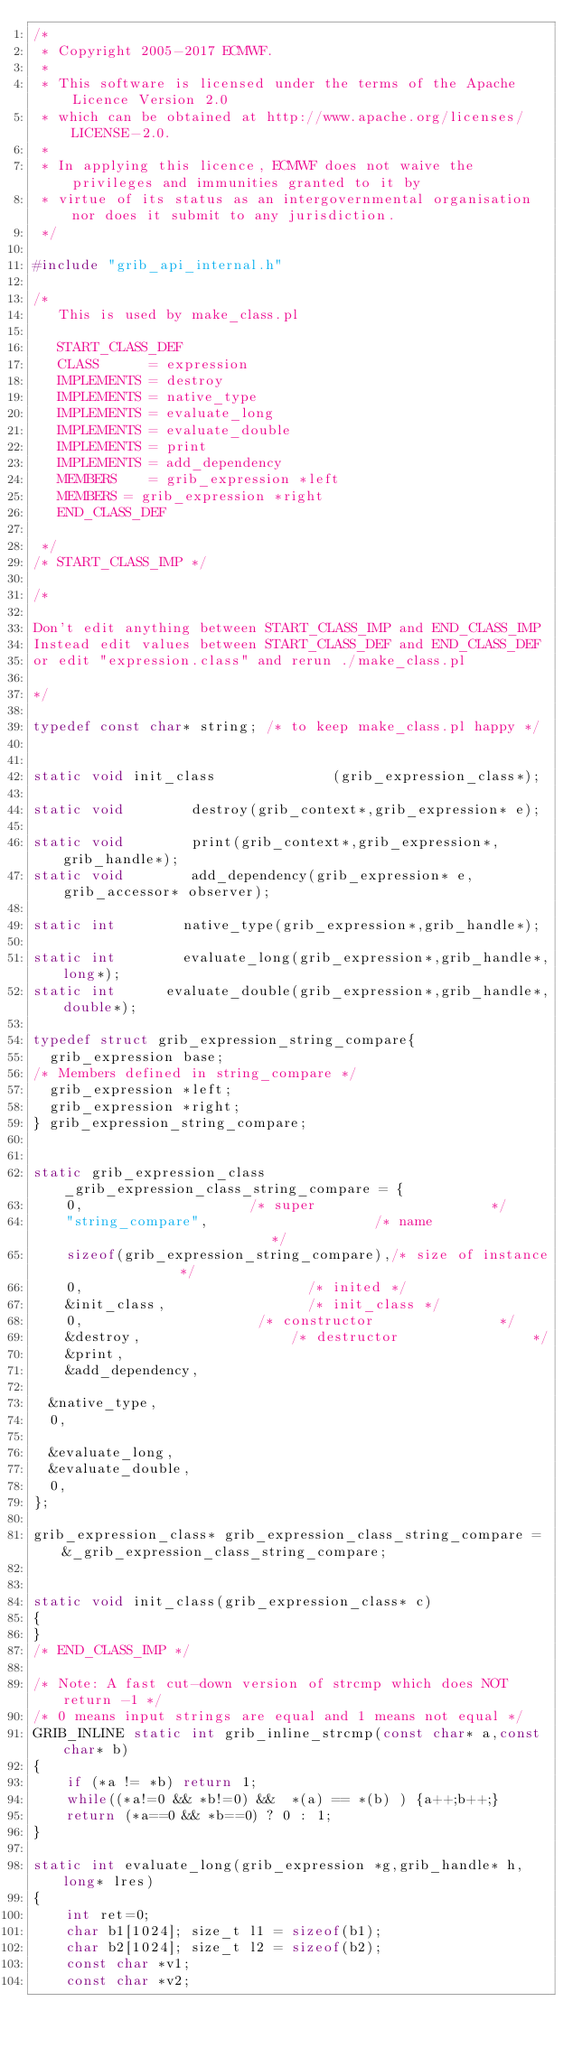Convert code to text. <code><loc_0><loc_0><loc_500><loc_500><_C_>/*
 * Copyright 2005-2017 ECMWF.
 *
 * This software is licensed under the terms of the Apache Licence Version 2.0
 * which can be obtained at http://www.apache.org/licenses/LICENSE-2.0.
 *
 * In applying this licence, ECMWF does not waive the privileges and immunities granted to it by
 * virtue of its status as an intergovernmental organisation nor does it submit to any jurisdiction.
 */

#include "grib_api_internal.h"

/*
   This is used by make_class.pl

   START_CLASS_DEF
   CLASS      = expression
   IMPLEMENTS = destroy
   IMPLEMENTS = native_type
   IMPLEMENTS = evaluate_long
   IMPLEMENTS = evaluate_double
   IMPLEMENTS = print
   IMPLEMENTS = add_dependency
   MEMBERS    = grib_expression *left
   MEMBERS = grib_expression *right
   END_CLASS_DEF

 */
/* START_CLASS_IMP */

/*

Don't edit anything between START_CLASS_IMP and END_CLASS_IMP
Instead edit values between START_CLASS_DEF and END_CLASS_DEF
or edit "expression.class" and rerun ./make_class.pl

*/

typedef const char* string; /* to keep make_class.pl happy */


static void init_class              (grib_expression_class*);

static void        destroy(grib_context*,grib_expression* e);

static void        print(grib_context*,grib_expression*,grib_handle*);
static void        add_dependency(grib_expression* e, grib_accessor* observer);

static int        native_type(grib_expression*,grib_handle*);

static int        evaluate_long(grib_expression*,grib_handle*,long*);
static int      evaluate_double(grib_expression*,grib_handle*,double*);

typedef struct grib_expression_string_compare{
  grib_expression base;
/* Members defined in string_compare */
	grib_expression *left;
	grib_expression *right;
} grib_expression_string_compare;


static grib_expression_class _grib_expression_class_string_compare = {
    0,                    /* super                     */
    "string_compare",                    /* name                      */
    sizeof(grib_expression_string_compare),/* size of instance          */
    0,                           /* inited */
    &init_class,                 /* init_class */
    0,                     /* constructor               */
    &destroy,                  /* destructor                */
    &print,                 
    &add_dependency,       

	&native_type,
	0,

	&evaluate_long,
	&evaluate_double,
	0,
};

grib_expression_class* grib_expression_class_string_compare = &_grib_expression_class_string_compare;


static void init_class(grib_expression_class* c)
{
}
/* END_CLASS_IMP */

/* Note: A fast cut-down version of strcmp which does NOT return -1 */
/* 0 means input strings are equal and 1 means not equal */
GRIB_INLINE static int grib_inline_strcmp(const char* a,const char* b)
{
    if (*a != *b) return 1;
    while((*a!=0 && *b!=0) &&  *(a) == *(b) ) {a++;b++;}
    return (*a==0 && *b==0) ? 0 : 1;
}

static int evaluate_long(grib_expression *g,grib_handle* h,long* lres)
{
    int ret=0;
    char b1[1024]; size_t l1 = sizeof(b1);
    char b2[1024]; size_t l2 = sizeof(b2);
    const char *v1;
    const char *v2;
</code> 